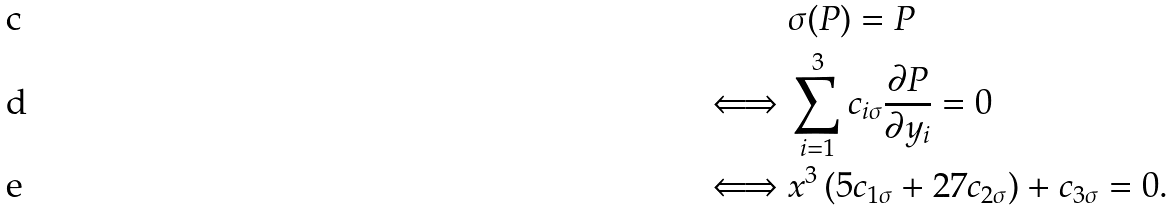Convert formula to latex. <formula><loc_0><loc_0><loc_500><loc_500>& \sigma ( P ) = P \\ \iff & \sum ^ { 3 } _ { i = 1 } c _ { i \sigma } \frac { \partial P } { \partial y _ { i } } = 0 \\ \iff & x ^ { 3 } \left ( 5 c _ { 1 \sigma } + 2 7 c _ { 2 \sigma } \right ) + c _ { 3 \sigma } = 0 .</formula> 